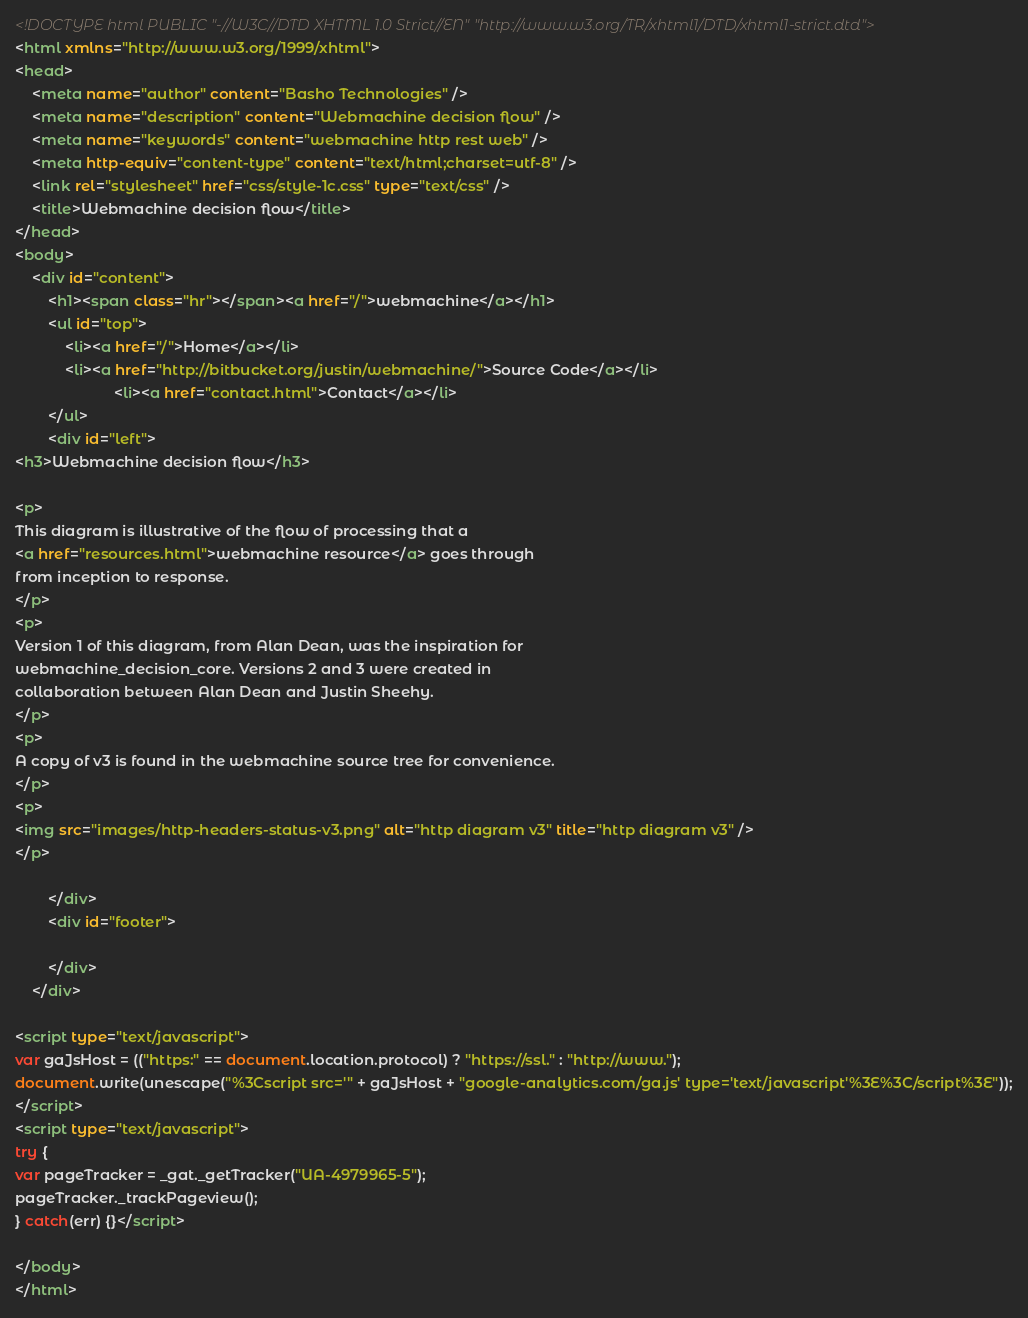<code> <loc_0><loc_0><loc_500><loc_500><_HTML_><!DOCTYPE html PUBLIC "-//W3C//DTD XHTML 1.0 Strict//EN" "http://www.w3.org/TR/xhtml1/DTD/xhtml1-strict.dtd">
<html xmlns="http://www.w3.org/1999/xhtml">
<head>
	<meta name="author" content="Basho Technologies" />
	<meta name="description" content="Webmachine decision flow" />
	<meta name="keywords" content="webmachine http rest web" />
    <meta http-equiv="content-type" content="text/html;charset=utf-8" />
	<link rel="stylesheet" href="css/style-1c.css" type="text/css" />
	<title>Webmachine decision flow</title>
</head>
<body>
	<div id="content">
		<h1><span class="hr"></span><a href="/">webmachine</a></h1>
		<ul id="top">
			<li><a href="/">Home</a></li>
			<li><a href="http://bitbucket.org/justin/webmachine/">Source Code</a></li>
                        <li><a href="contact.html">Contact</a></li>
		</ul>
		<div id="left">
<h3>Webmachine decision flow</h3>

<p>
This diagram is illustrative of the flow of processing that a
<a href="resources.html">webmachine resource</a> goes through
from inception to response.
</p>
<p>
Version 1 of this diagram, from Alan Dean, was the inspiration for
webmachine_decision_core. Versions 2 and 3 were created in
collaboration between Alan Dean and Justin Sheehy.
</p>
<p>
A copy of v3 is found in the webmachine source tree for convenience.
</p>
<p>
<img src="images/http-headers-status-v3.png" alt="http diagram v3" title="http diagram v3" />
</p>

		</div>
		<div id="footer">

		</div>
	</div>

<script type="text/javascript">
var gaJsHost = (("https:" == document.location.protocol) ? "https://ssl." : "http://www.");
document.write(unescape("%3Cscript src='" + gaJsHost + "google-analytics.com/ga.js' type='text/javascript'%3E%3C/script%3E"));
</script>
<script type="text/javascript">
try {
var pageTracker = _gat._getTracker("UA-4979965-5");
pageTracker._trackPageview();
} catch(err) {}</script>

</body>
</html>

</code> 